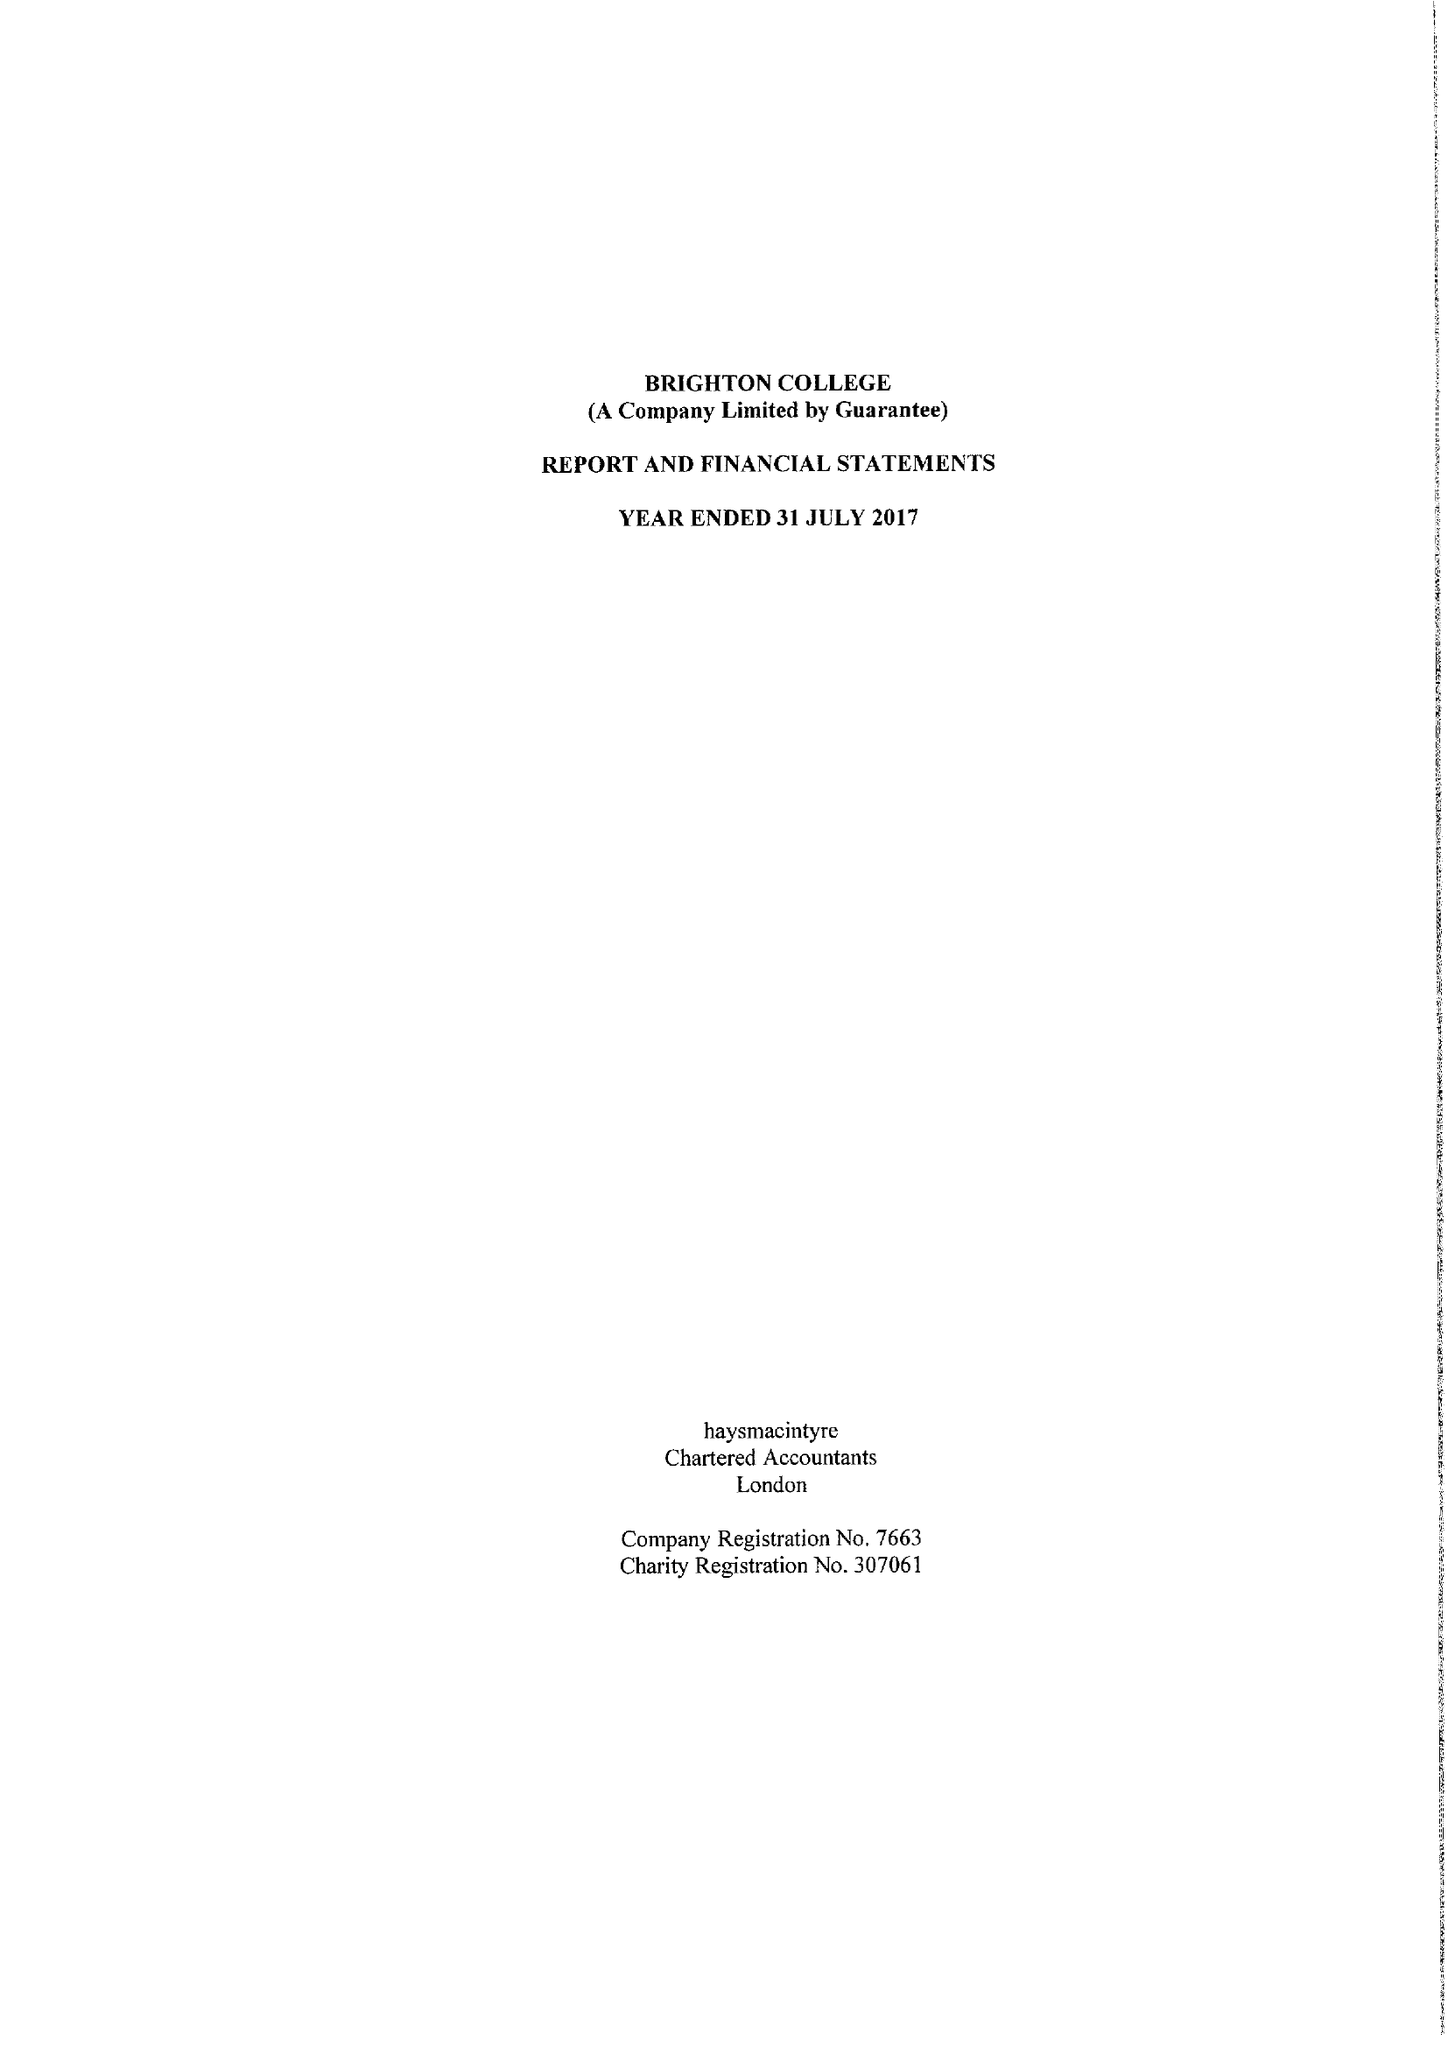What is the value for the report_date?
Answer the question using a single word or phrase. 2017-07-31 